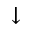<formula> <loc_0><loc_0><loc_500><loc_500>\downarrow</formula> 